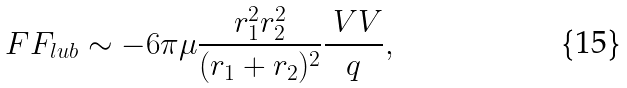Convert formula to latex. <formula><loc_0><loc_0><loc_500><loc_500>\ F F _ { l u b } \sim - 6 \pi \mu \frac { r _ { 1 } ^ { 2 } r _ { 2 } ^ { 2 } } { ( r _ { 1 } + r _ { 2 } ) ^ { 2 } } \frac { \ V V } { q } ,</formula> 